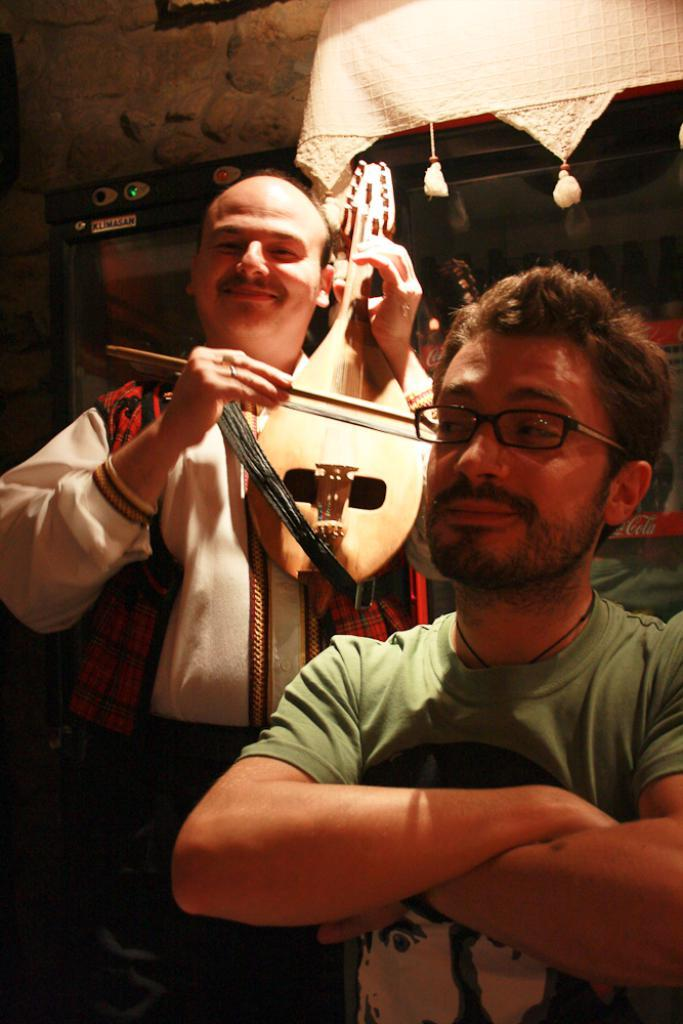How many people are in the image? There are two persons in the image. What is one of the persons wearing? One of the persons is wearing spectacles. What is the person wearing spectacles doing? The person with spectacles is playing a guitar. What can be seen in the background of the image? There is a wall in the background of the image. What type of quiver is the person with spectacles using to play the guitar? There is no quiver present in the image, and the person with spectacles is not using any such item to play the guitar. 